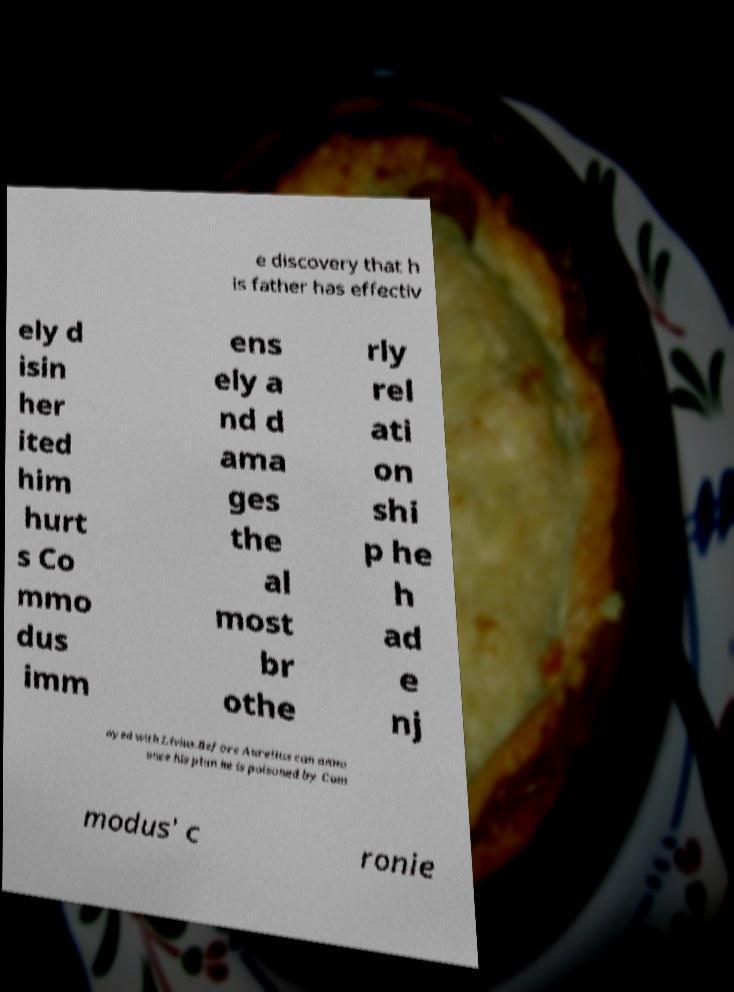What messages or text are displayed in this image? I need them in a readable, typed format. e discovery that h is father has effectiv ely d isin her ited him hurt s Co mmo dus imm ens ely a nd d ama ges the al most br othe rly rel ati on shi p he h ad e nj oyed with Livius.Before Aurelius can anno unce his plan he is poisoned by Com modus' c ronie 